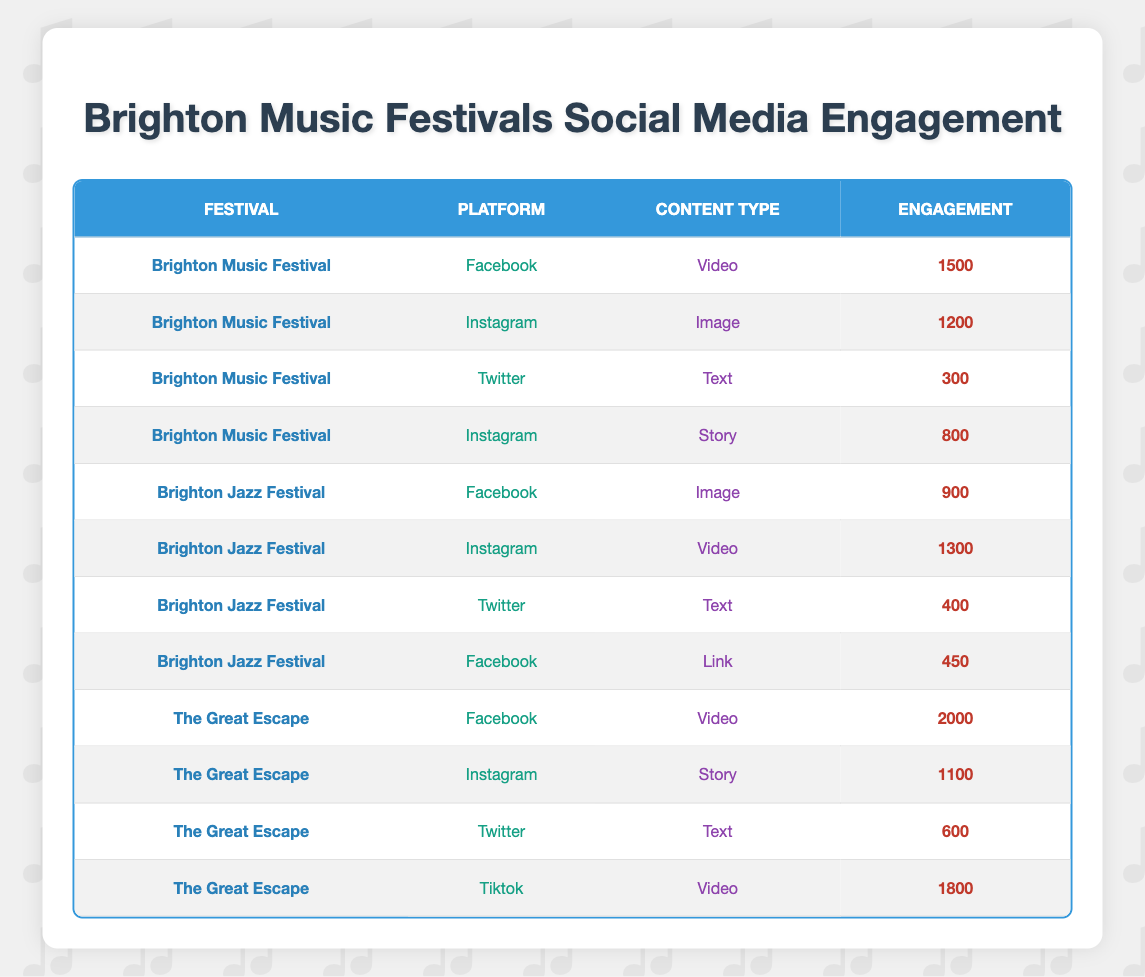What is the highest engagement from Brighton Music Festival? The highest engagement from Brighton Music Festival is found under the Facebook platform for Video content, where it shows an engagement of 1500.
Answer: 1500 Which platform had the lowest engagement in the Brighton Jazz Festival? Looking at all the rows related to the Brighton Jazz Festival, the Twitter platform with Text content has the lowest engagement, which is 400.
Answer: 400 For which festival did the Tiktok platform generate the most engagement? The data shows that the highest engagement on the Tiktok platform is from The Great Escape festival with a Video content engagement of 1800.
Answer: The Great Escape What is the sum of the engagements for all Instagram content types across the festivals? The Instagram content types engagements are 1200 (Brighton Music Festival, Image) + 1300 (Brighton Jazz Festival, Video) + 1100 (The Great Escape, Story) = 3600.
Answer: 3600 Is it true that the Facebook platform had more engagement than video content on Instagram in any festival? By comparing engagements, the Facebook Video engagement for The Great Escape is 2000, which is higher than any Instagram video engagement, so the statement is true.
Answer: Yes What is the average engagement for Twitter content types across all festivals? The Twitter engagements are 300 (Brighton Music Festival, Text) + 400 (Brighton Jazz Festival, Text) + 600 (The Great Escape, Text) = 1300. Dividing this total by 3 gives an average of 1300/3, which is approximately 433.33.
Answer: 433.33 Which content type had the highest engagement overall? By inspecting the engagement values, the Tiktok Video content from The Great Escape shows the highest engagement of 1800 compared to others in the table.
Answer: 1800 Did Brighton Music Festival engage more on Facebook or Instagram? Facebook engagement for Brighton Music Festival is 1500 and Instagram transactions are 1200 (Image) and 800 (Story), so total Instagram is 2000, confirming it engaged more on Instagram.
Answer: Yes 